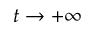Convert formula to latex. <formula><loc_0><loc_0><loc_500><loc_500>t \to + \infty</formula> 